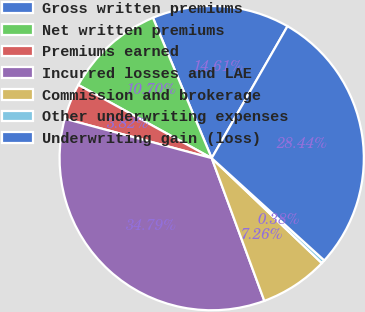Convert chart. <chart><loc_0><loc_0><loc_500><loc_500><pie_chart><fcel>Gross written premiums<fcel>Net written premiums<fcel>Premiums earned<fcel>Incurred losses and LAE<fcel>Commission and brokerage<fcel>Other underwriting expenses<fcel>Underwriting gain (loss)<nl><fcel>14.61%<fcel>10.7%<fcel>3.82%<fcel>34.79%<fcel>7.26%<fcel>0.38%<fcel>28.44%<nl></chart> 